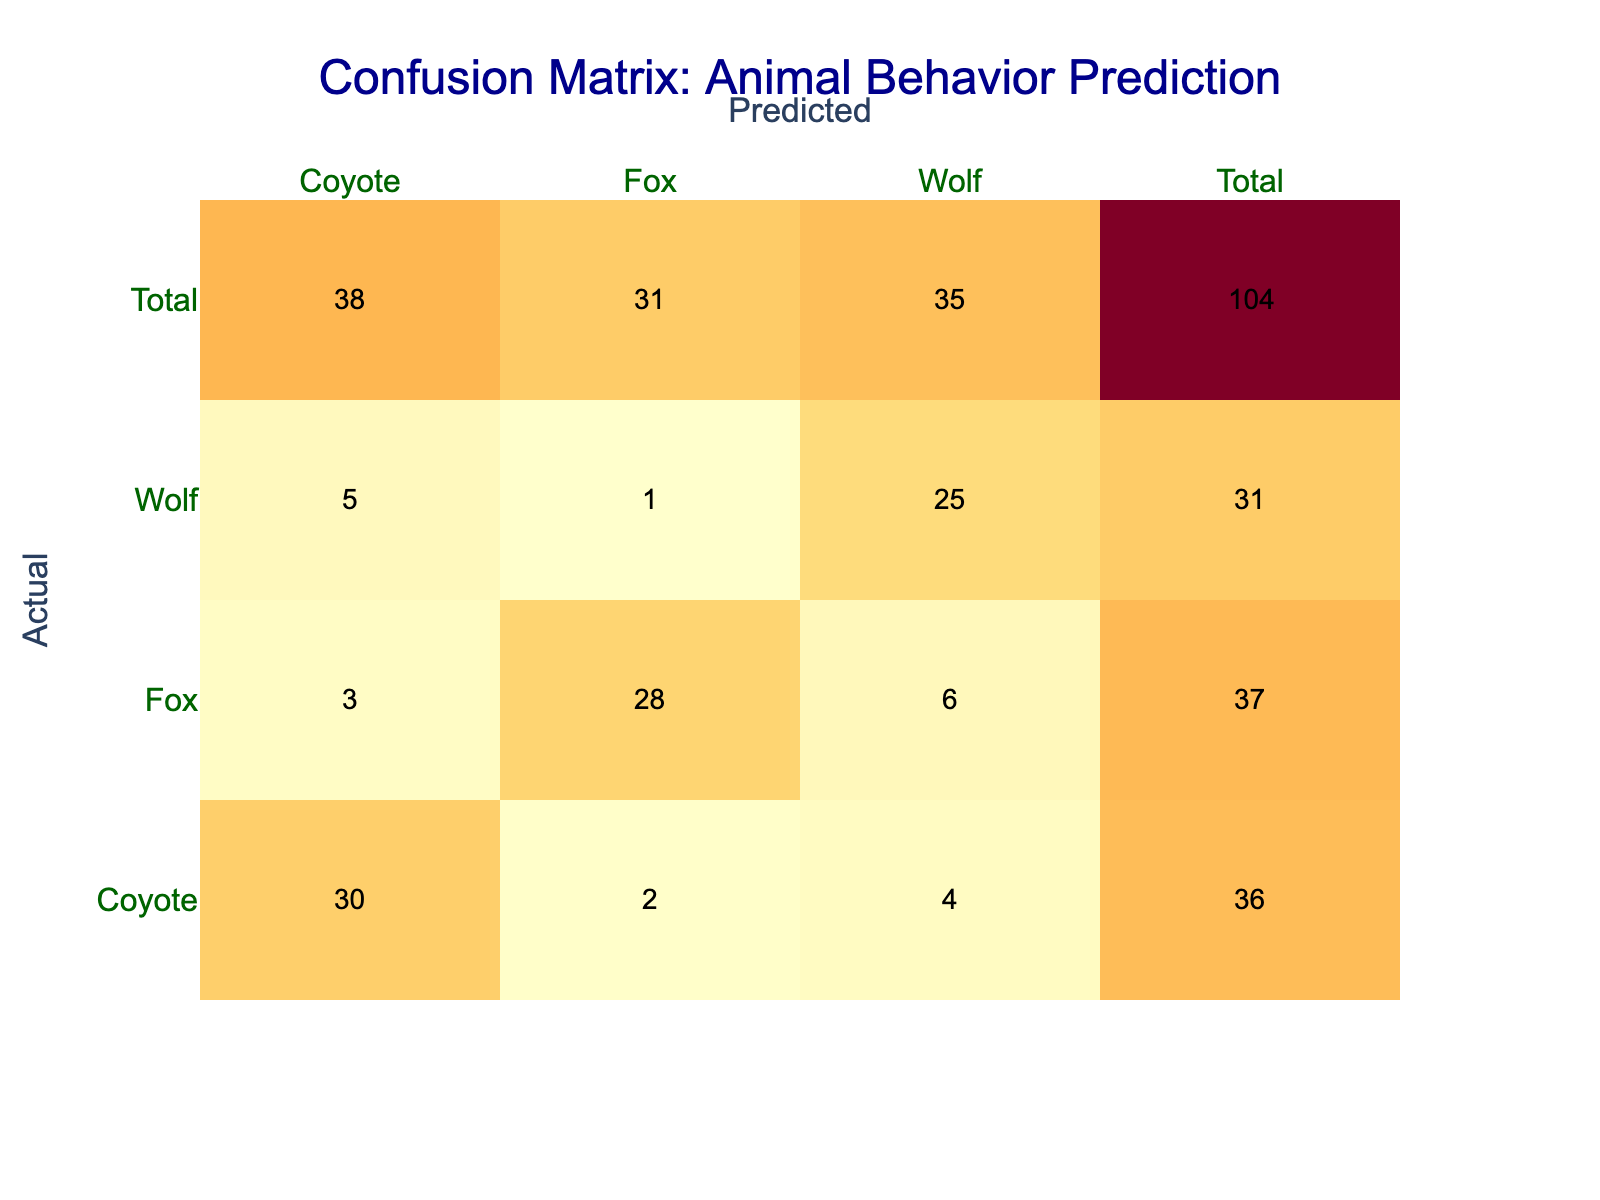What is the predicted count for Fox when the actual is Fox? From the table, we can see the row for "Fox" as the actual category and look at the corresponding value in the column for "Fox" under predicted. The cell indicates a count of 28.
Answer: 28 What is the total number of Coyote instances classified as Wolf? We find the cell where the actual is Coyote and the predicted is Wolf. Referring to the table, the count is 5.
Answer: 5 Is the predicted count for Wolf greater than that for Fox when the actual is Coyote? Looking at the actual Coyote row, the predicted counts are 5 for Wolf and 2 for Fox. Since 5 is greater than 2, the answer is yes.
Answer: Yes What is the total number of instances predicted as Wolf? To find this total, we need to sum the values in the Wolf column. The counts are 4 (Coyote) + 25 (Wolf) + 6 (Fox) = 35.
Answer: 35 What is the difference between the total predicted counts for Coyote and Fox? First, we find the total for Coyote: 30 (Coyote) + 5 (Wolf) + 3 (Fox) = 38. Next, for Fox: 2 (Coyote) + 1 (Wolf) + 28 (Fox) = 31. The difference is 38 - 31 = 7.
Answer: 7 How many instances were truly classified correctly as Wolf? The table shows that the actual instances of Wolf that were predicted correctly are 25. This is located in the cell where the actual is Wolf and the predicted is Wolf.
Answer: 25 What is the average predicted count for all categories when the actual behavior is Coyote? The total predicted counts for actual Coyote are: 30 (for Coyote) + 5 (for Wolf) + 3 (for Fox) = 38. There are 3 categories (Coyote, Wolf, Fox), so the average is 38 / 3 = 12.67.
Answer: 12.67 Is there a higher count for actual Coyote predictions or actual Fox predictions when it comes to misclassifications? Looking at misclassifications: actual Coyote predictions that didn’t match Coyote (5 for Wolf + 3 for Fox = 8), and actual Fox predictions that didn’t match Fox (2 for Coyote + 1 for Wolf = 3). Since 8 is greater than 3, the answer is yes.
Answer: Yes 